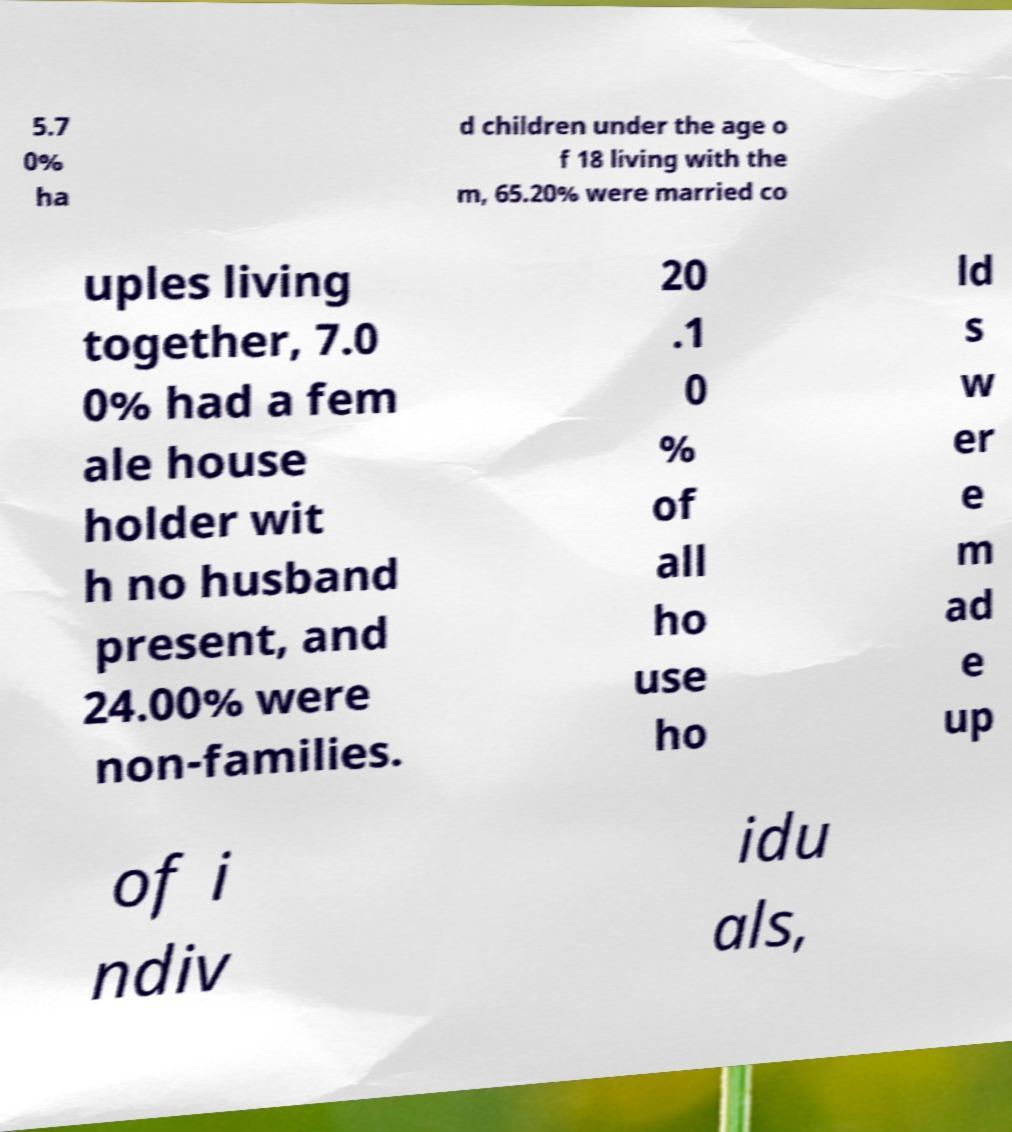Could you extract and type out the text from this image? 5.7 0% ha d children under the age o f 18 living with the m, 65.20% were married co uples living together, 7.0 0% had a fem ale house holder wit h no husband present, and 24.00% were non-families. 20 .1 0 % of all ho use ho ld s w er e m ad e up of i ndiv idu als, 